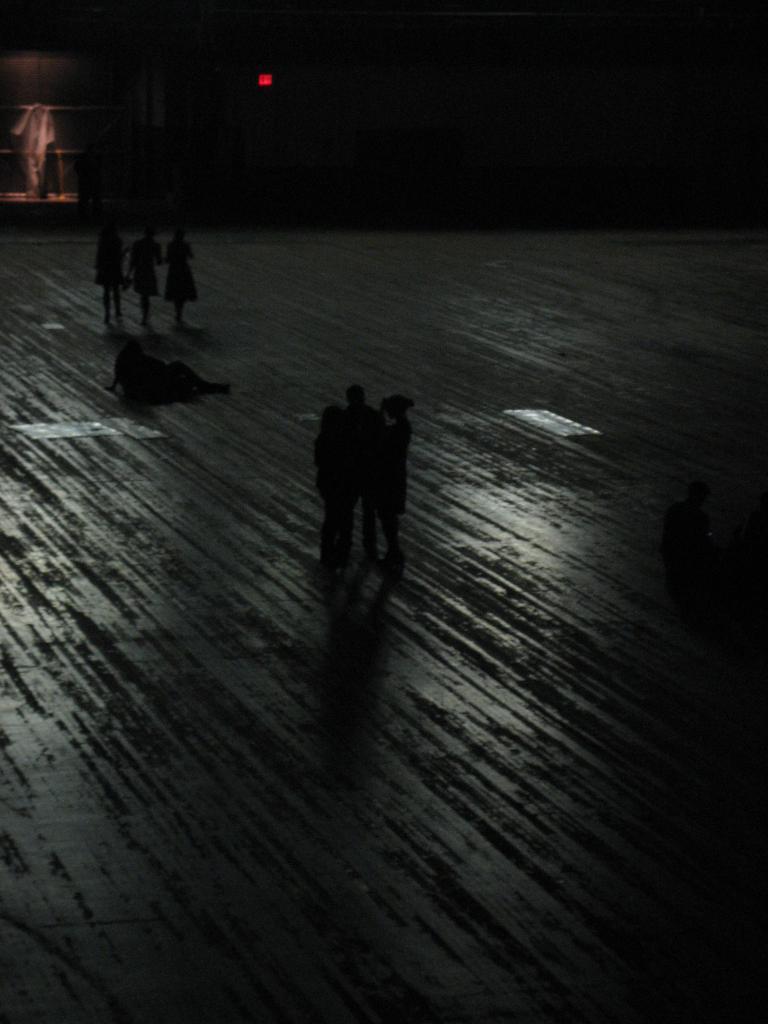Please provide a concise description of this image. In this image we can see people. In the background there is a wall and we can see a light. 